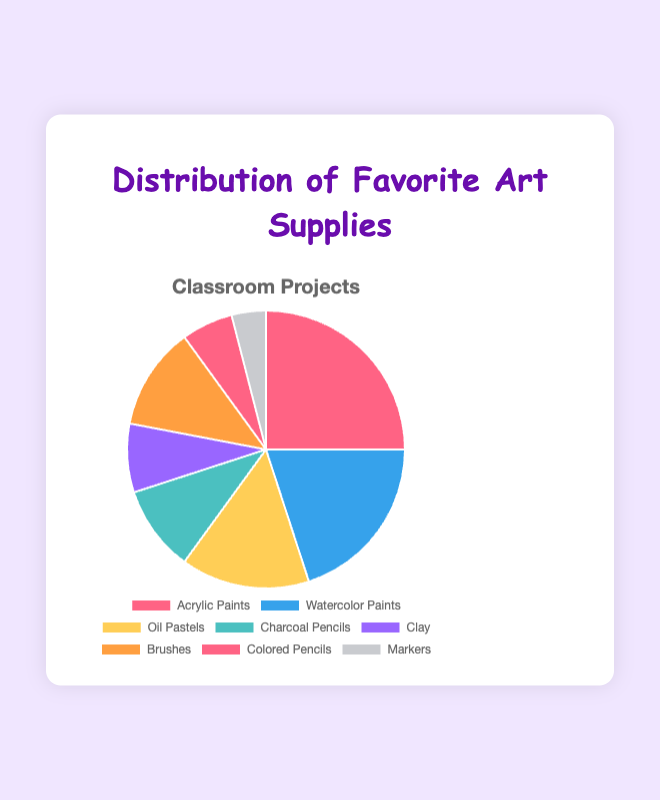Which art supply is the most popular? By looking at the pie chart, the largest slice represents the most popular art supply. The largest slice is for Acrylic Paints with 25%.
Answer: Acrylic Paints Which art supply has the smallest percentage? The smallest slice in the pie chart represents the least popular art supply. The slice for Markers is the smallest with 4%.
Answer: Markers How much more popular are Brushes compared to Markers? Brushes account for 12% and Markers for 4%. To find how much more popular Brushes are, subtract the percentage of Markers from that of Brushes: 12% - 4% = 8%.
Answer: 8% What is the combined percentage of Acrylic Paints and Watercolor Paints? Acrylic Paints account for 25% and Watercolor Paints for 20%. Add these two percentages together: 25% + 20% = 45%.
Answer: 45% Which art supplies have a combined percentage equal to or less than Clay (8%)? Look for all slices in the pie chart with percentages equal to or less than 8%. Colored Pencils (6%) and Markers (4%) have percentages less than 8%.
Answer: Colored Pencils and Markers Are Oil Pastels more or less popular than Charcoal Pencils? Compare the slices representing Oil Pastels and Charcoal Pencils in the pie chart. Oil Pastels have 15% and Charcoal Pencils have 10%. Thus, Oil Pastels are more popular than Charcoal Pencils.
Answer: More What percentage of the classroom projects use either Charcoal Pencils or Clay? Find the slices representing Charcoal Pencils (10%) and Clay (8%), and add their percentages together: 10% + 8% = 18%.
Answer: 18% If we were to group Watercolor Paints, Brushes, and Colored Pencils together, what would be their total percentage? Calculate the combined percentage by adding Watercolor Paints (20%), Brushes (12%), and Colored Pencils (6%): 20% + 12% + 6% = 38%.
Answer: 38% Is the percentage for Acrylic Paints more than double that of Charcoal Pencils? Compare the percentage for Acrylic Paints (25%) and double the percentage of Charcoal Pencils (10% x 2 = 20%). Since 25% is more than 20%, Acrylic Paints are more than double Charcoal Pencils.
Answer: Yes 